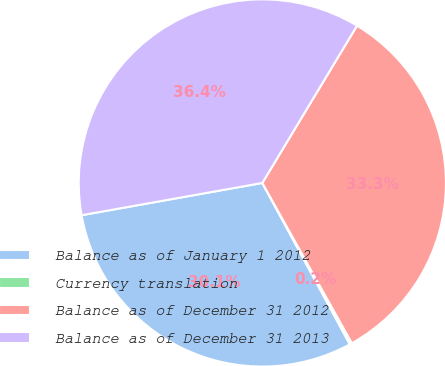Convert chart. <chart><loc_0><loc_0><loc_500><loc_500><pie_chart><fcel>Balance as of January 1 2012<fcel>Currency translation<fcel>Balance as of December 31 2012<fcel>Balance as of December 31 2013<nl><fcel>30.1%<fcel>0.2%<fcel>33.27%<fcel>36.44%<nl></chart> 